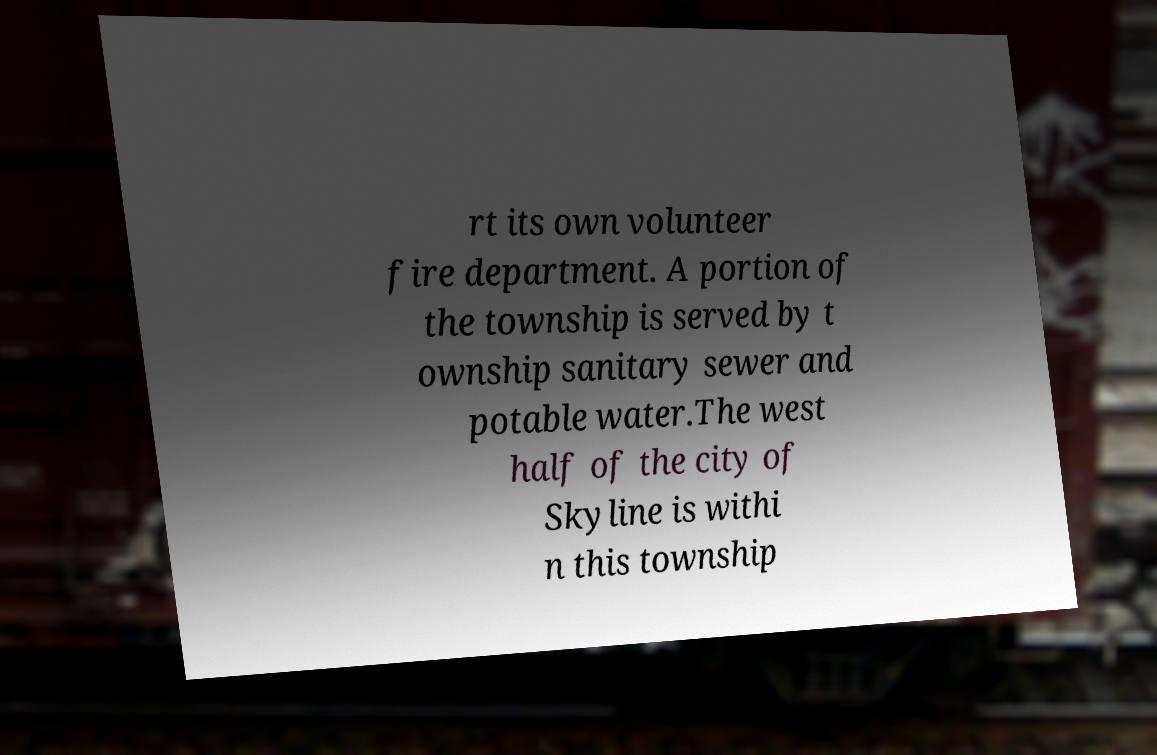Can you read and provide the text displayed in the image?This photo seems to have some interesting text. Can you extract and type it out for me? rt its own volunteer fire department. A portion of the township is served by t ownship sanitary sewer and potable water.The west half of the city of Skyline is withi n this township 